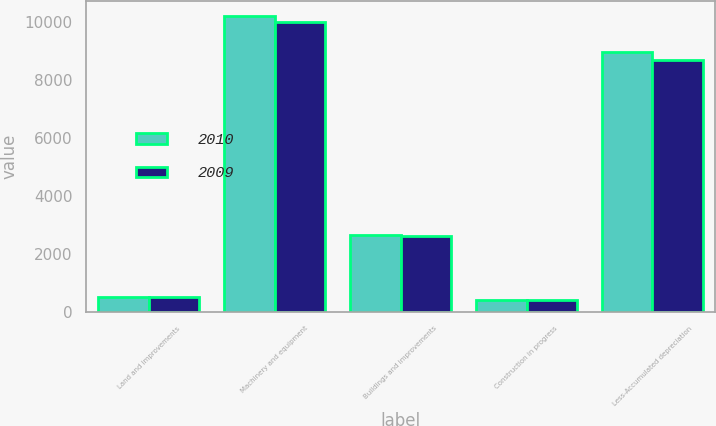<chart> <loc_0><loc_0><loc_500><loc_500><stacked_bar_chart><ecel><fcel>Land and improvements<fcel>Machinery and equipment<fcel>Buildings and improvements<fcel>Construction in progress<fcel>Less-Accumulated depreciation<nl><fcel>2010<fcel>525<fcel>10204<fcel>2669<fcel>403<fcel>8961<nl><fcel>2009<fcel>513<fcel>9982<fcel>2621<fcel>405<fcel>8674<nl></chart> 